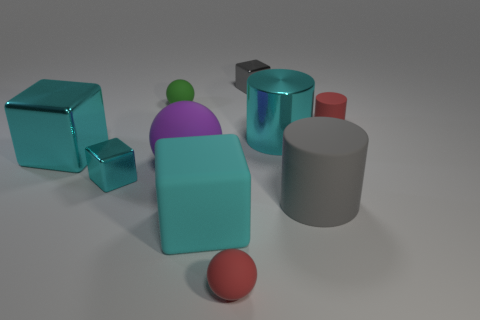How many cyan cubes must be subtracted to get 1 cyan cubes? 2 Subtract all tiny balls. How many balls are left? 1 Subtract all gray blocks. How many blocks are left? 3 Subtract all green spheres. How many cyan cubes are left? 3 Subtract 1 spheres. How many spheres are left? 2 Add 8 tiny cyan metallic objects. How many tiny cyan metallic objects are left? 9 Add 6 big cylinders. How many big cylinders exist? 8 Subtract 0 purple cylinders. How many objects are left? 10 Subtract all balls. How many objects are left? 7 Subtract all brown balls. Subtract all gray cylinders. How many balls are left? 3 